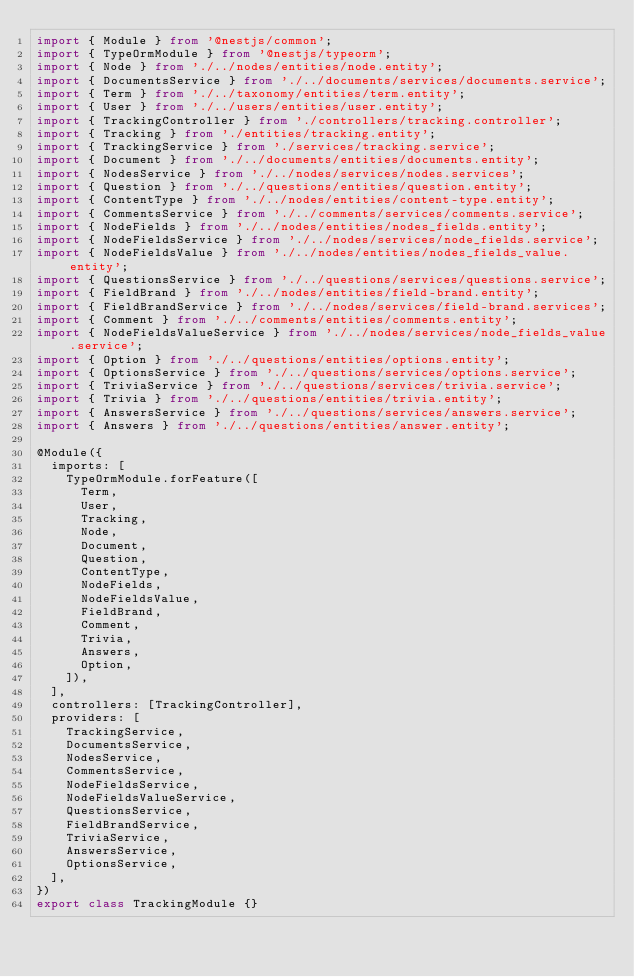<code> <loc_0><loc_0><loc_500><loc_500><_TypeScript_>import { Module } from '@nestjs/common';
import { TypeOrmModule } from '@nestjs/typeorm';
import { Node } from './../nodes/entities/node.entity';
import { DocumentsService } from './../documents/services/documents.service';
import { Term } from './../taxonomy/entities/term.entity';
import { User } from './../users/entities/user.entity';
import { TrackingController } from './controllers/tracking.controller';
import { Tracking } from './entities/tracking.entity';
import { TrackingService } from './services/tracking.service';
import { Document } from './../documents/entities/documents.entity';
import { NodesService } from './../nodes/services/nodes.services';
import { Question } from './../questions/entities/question.entity';
import { ContentType } from './../nodes/entities/content-type.entity';
import { CommentsService } from './../comments/services/comments.service';
import { NodeFields } from './../nodes/entities/nodes_fields.entity';
import { NodeFieldsService } from './../nodes/services/node_fields.service';
import { NodeFieldsValue } from './../nodes/entities/nodes_fields_value.entity';
import { QuestionsService } from './../questions/services/questions.service';
import { FieldBrand } from './../nodes/entities/field-brand.entity';
import { FieldBrandService } from './../nodes/services/field-brand.services';
import { Comment } from './../comments/entities/comments.entity';
import { NodeFieldsValueService } from './../nodes/services/node_fields_value.service';
import { Option } from './../questions/entities/options.entity';
import { OptionsService } from './../questions/services/options.service';
import { TriviaService } from './../questions/services/trivia.service';
import { Trivia } from './../questions/entities/trivia.entity';
import { AnswersService } from './../questions/services/answers.service';
import { Answers } from './../questions/entities/answer.entity';

@Module({
  imports: [
    TypeOrmModule.forFeature([
      Term,
      User,
      Tracking,
      Node,
      Document,
      Question,
      ContentType,
      NodeFields,
      NodeFieldsValue,
      FieldBrand,
      Comment,
      Trivia,
      Answers,
      Option,
    ]),
  ],
  controllers: [TrackingController],
  providers: [
    TrackingService,
    DocumentsService,
    NodesService,
    CommentsService,
    NodeFieldsService,
    NodeFieldsValueService,
    QuestionsService,
    FieldBrandService,
    TriviaService,
    AnswersService,
    OptionsService,
  ],
})
export class TrackingModule {}
</code> 